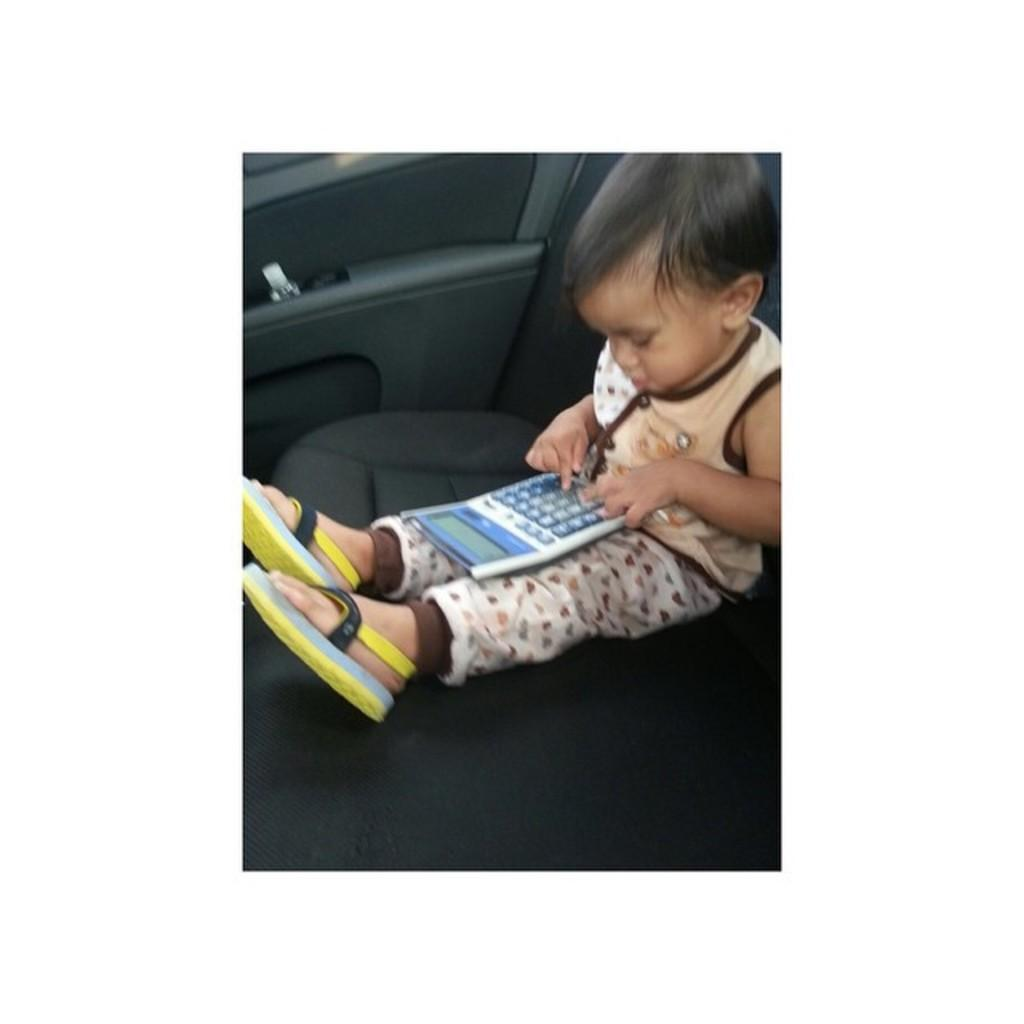What is the main subject of the image? The main subject of the image is a kid. Where is the kid located in the image? The kid is sitting on the seat of a vehicle. What is the kid holding or using in the image? The kid has a calculator on his lap and is pressing the buttons on the calculator. What type of footwear is the kid wearing? The kid is wearing footwear. What type of tin can be seen in the image? There is no tin present in the image. What kind of food is the kid eating in the image? The image does not show the kid eating any food. 